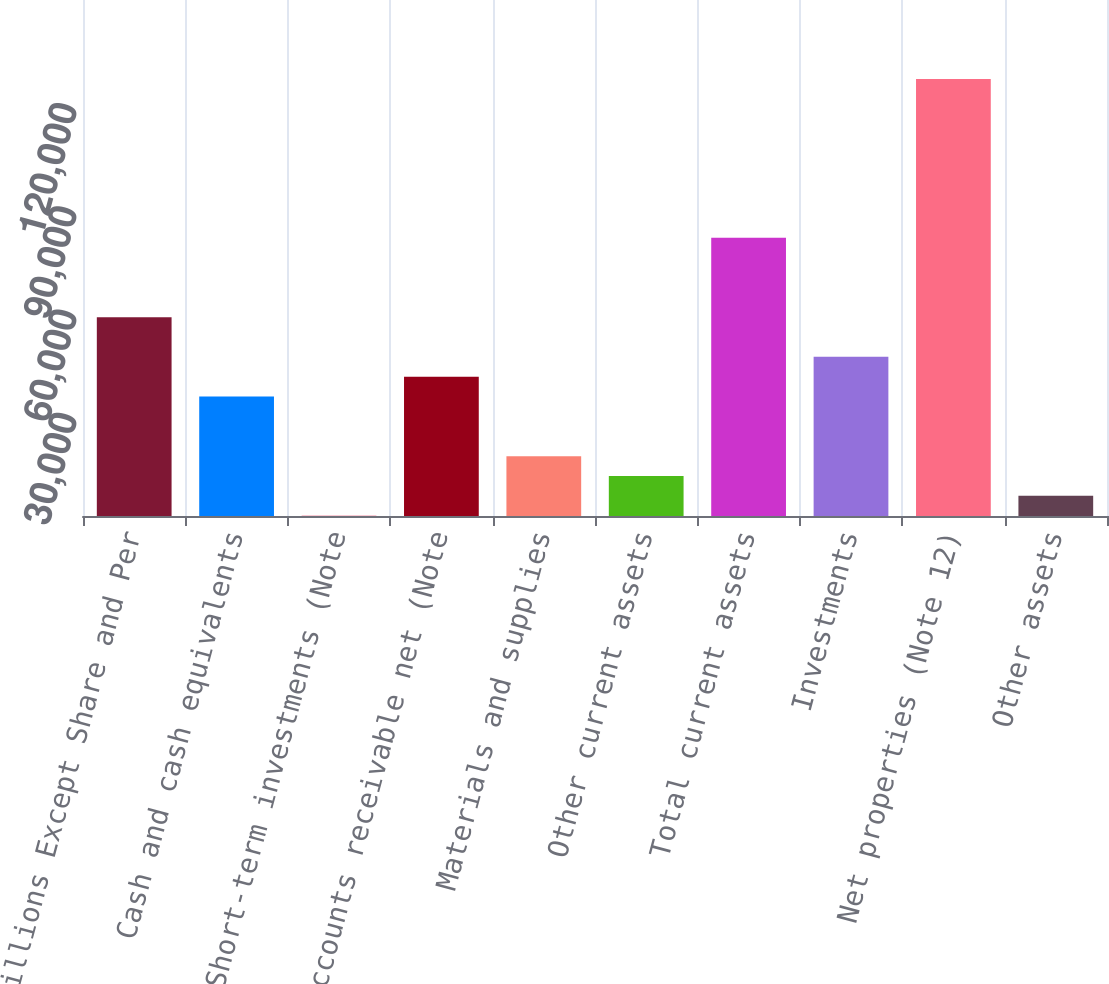<chart> <loc_0><loc_0><loc_500><loc_500><bar_chart><fcel>Millions Except Share and Per<fcel>Cash and cash equivalents<fcel>Short-term investments (Note<fcel>Accounts receivable net (Note<fcel>Materials and supplies<fcel>Other current assets<fcel>Total current assets<fcel>Investments<fcel>Net properties (Note 12)<fcel>Other assets<nl><fcel>57806<fcel>34719.6<fcel>90<fcel>40491.2<fcel>17404.8<fcel>11633.2<fcel>80892.4<fcel>46262.8<fcel>127065<fcel>5861.6<nl></chart> 